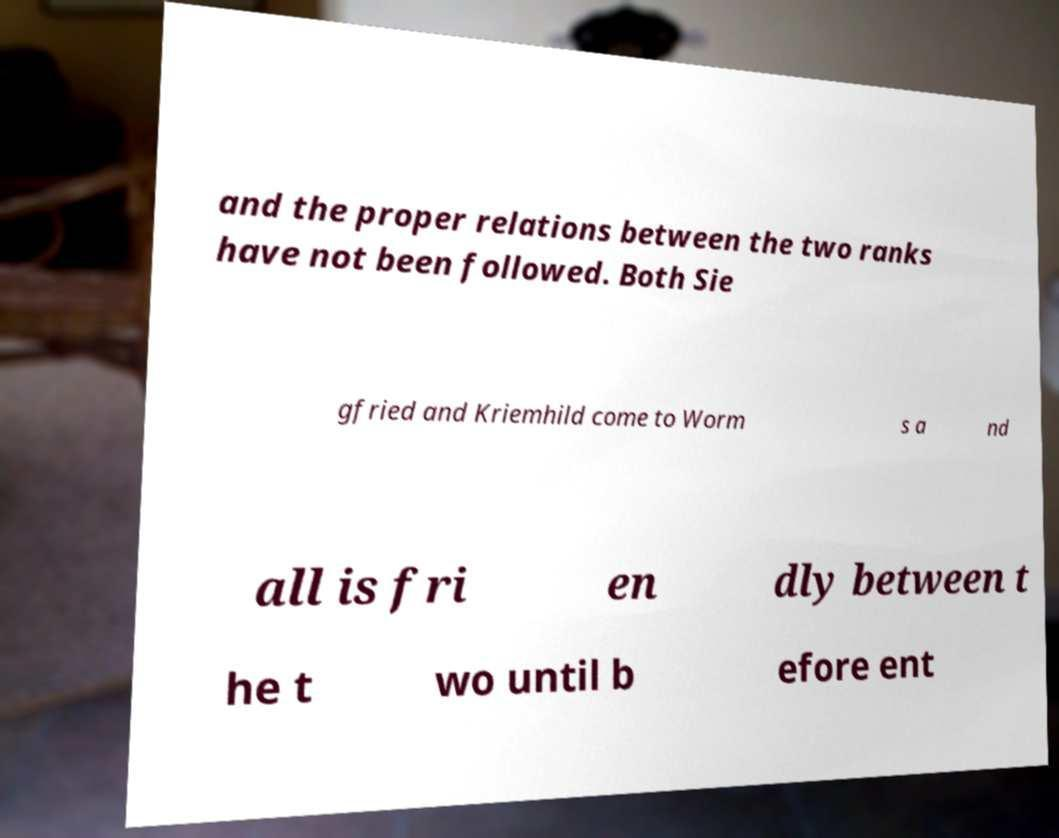Can you accurately transcribe the text from the provided image for me? and the proper relations between the two ranks have not been followed. Both Sie gfried and Kriemhild come to Worm s a nd all is fri en dly between t he t wo until b efore ent 